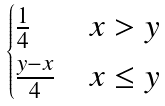Convert formula to latex. <formula><loc_0><loc_0><loc_500><loc_500>\begin{cases} \frac { 1 } { 4 } & x > y \\ \frac { y - x } { 4 } & x \leq y \end{cases}</formula> 